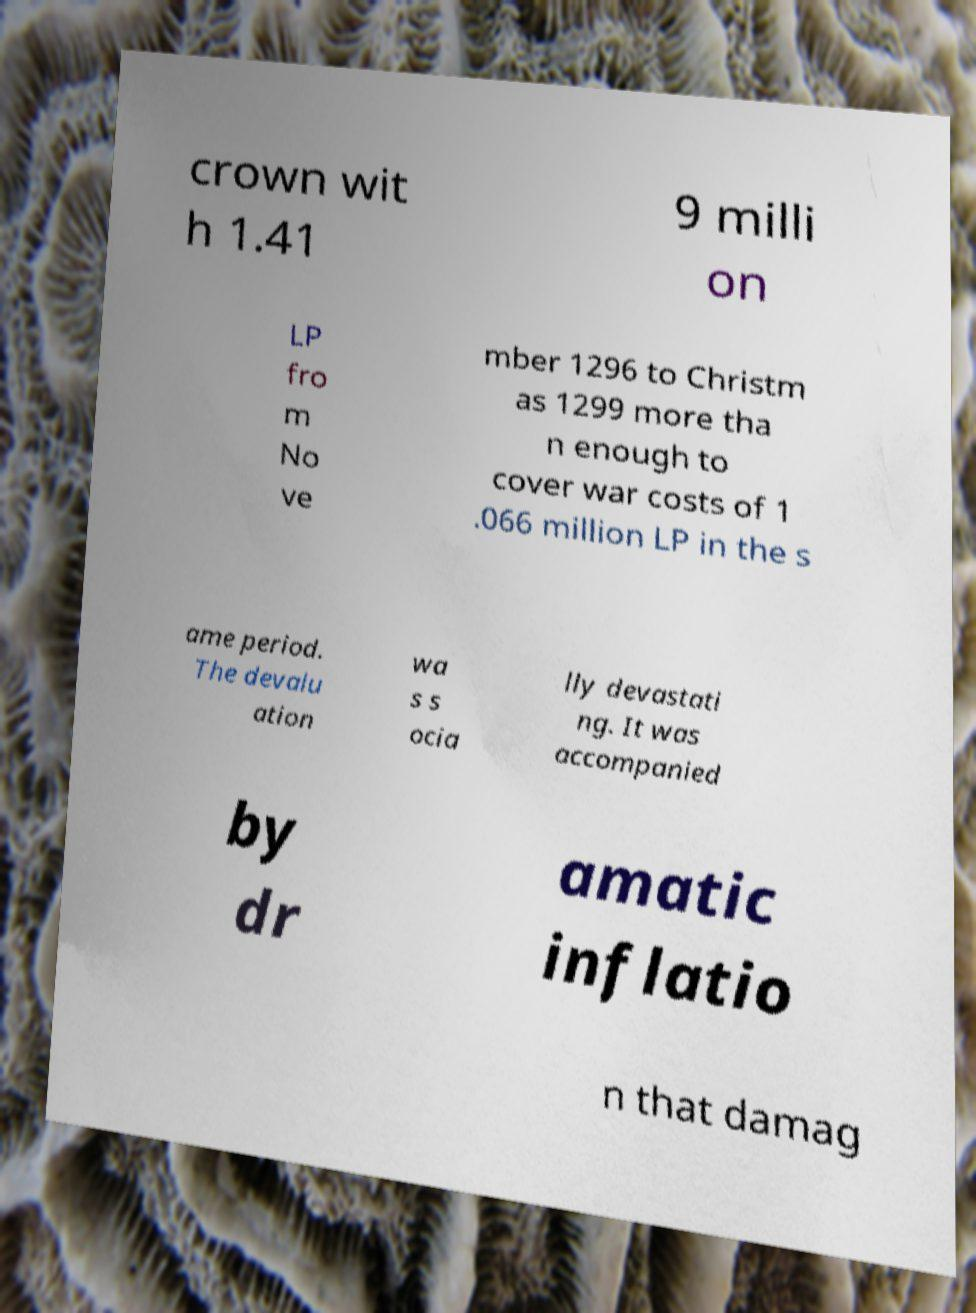I need the written content from this picture converted into text. Can you do that? crown wit h 1.41 9 milli on LP fro m No ve mber 1296 to Christm as 1299 more tha n enough to cover war costs of 1 .066 million LP in the s ame period. The devalu ation wa s s ocia lly devastati ng. It was accompanied by dr amatic inflatio n that damag 